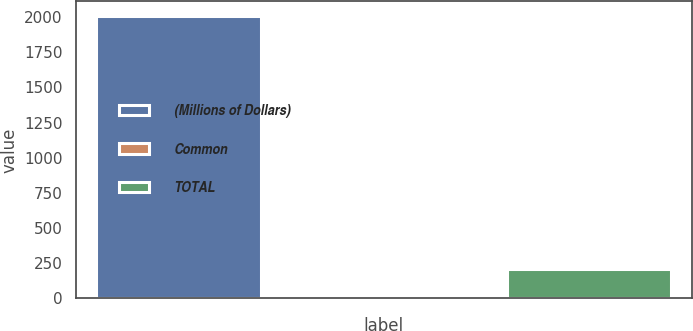Convert chart. <chart><loc_0><loc_0><loc_500><loc_500><bar_chart><fcel>(Millions of Dollars)<fcel>Common<fcel>TOTAL<nl><fcel>2011<fcel>6<fcel>206.5<nl></chart> 